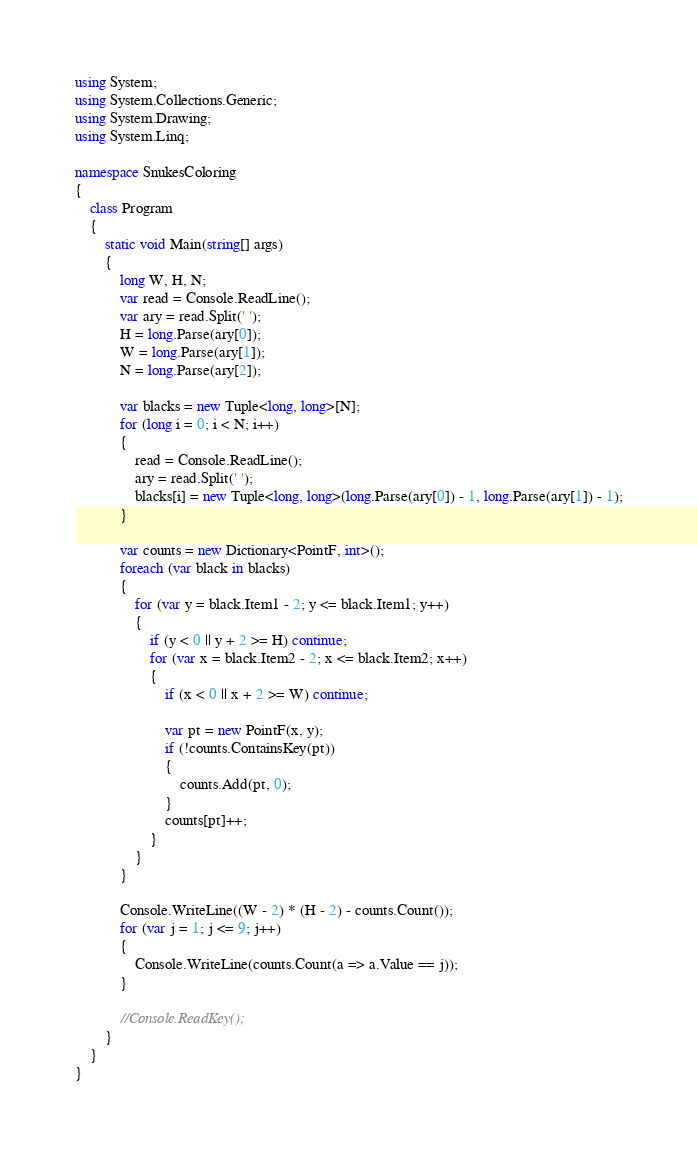Convert code to text. <code><loc_0><loc_0><loc_500><loc_500><_C#_>using System;
using System.Collections.Generic;
using System.Drawing;
using System.Linq;

namespace SnukesColoring
{
    class Program
    {
        static void Main(string[] args)
        {
            long W, H, N;
            var read = Console.ReadLine();
            var ary = read.Split(' ');
            H = long.Parse(ary[0]);
            W = long.Parse(ary[1]);
            N = long.Parse(ary[2]);

            var blacks = new Tuple<long, long>[N];
            for (long i = 0; i < N; i++)
            {
                read = Console.ReadLine();
                ary = read.Split(' ');
                blacks[i] = new Tuple<long, long>(long.Parse(ary[0]) - 1, long.Parse(ary[1]) - 1);
            }

            var counts = new Dictionary<PointF, int>();
            foreach (var black in blacks)
            {
                for (var y = black.Item1 - 2; y <= black.Item1; y++)
                {
                    if (y < 0 || y + 2 >= H) continue;
                    for (var x = black.Item2 - 2; x <= black.Item2; x++)
                    {
                        if (x < 0 || x + 2 >= W) continue;

                        var pt = new PointF(x, y);
                        if (!counts.ContainsKey(pt))
                        {
                            counts.Add(pt, 0);
                        }
                        counts[pt]++;
                    }
                }
            }

            Console.WriteLine((W - 2) * (H - 2) - counts.Count());
            for (var j = 1; j <= 9; j++)
            {
                Console.WriteLine(counts.Count(a => a.Value == j));
            }

            //Console.ReadKey();
        }
    }
}
</code> 